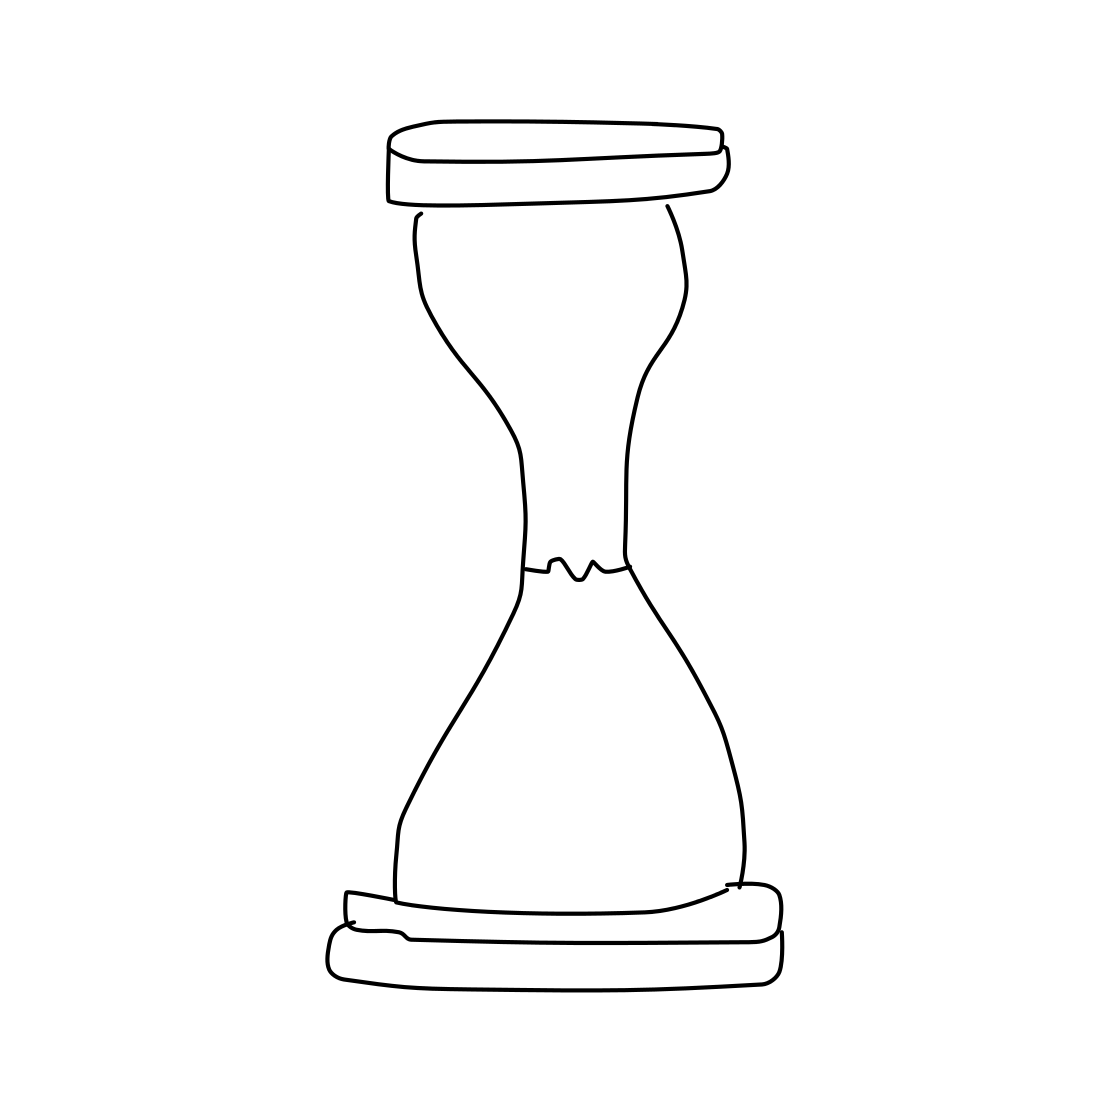What kind of style is the hourglass drawn in? The hourglass is drawn in a minimalist, sketch-like style, emphasizing clean lines and devoid of intricate details or shading. Could this hourglass design be part of any specific art movement? While this sketch doesn't belong to a specific art movement, its minimalist aesthetic could be associated with modern art movements that favor simplicity and abstraction. 